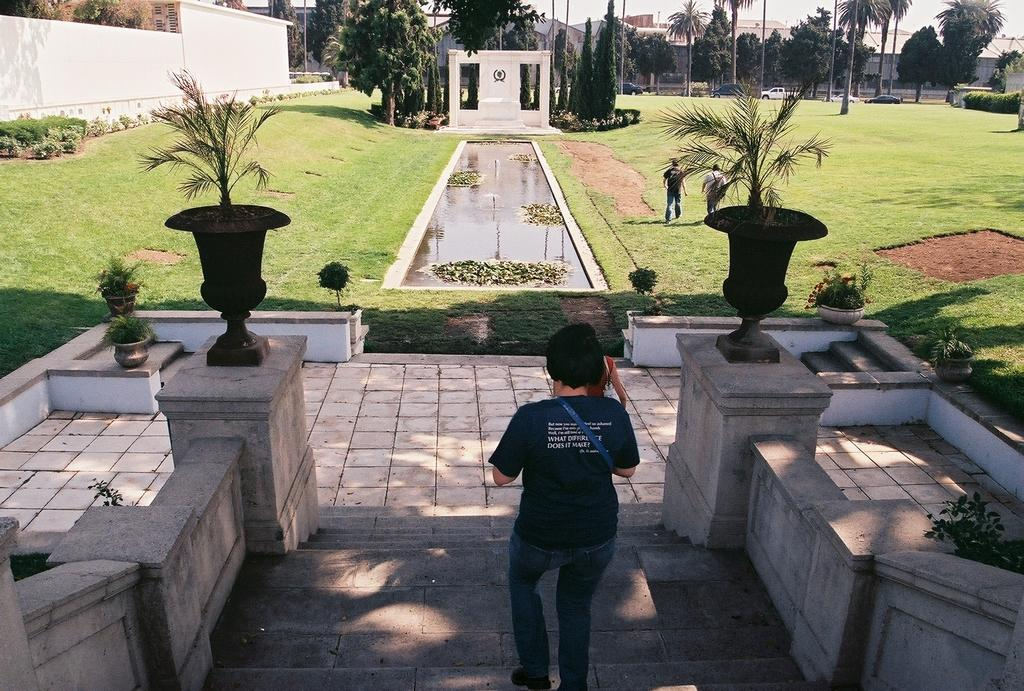How many people are in the image? There are people in the image, but the exact number is not specified. What can be seen in the image besides the people? There are stairs, plants, trees, a pond, buildings, cars, and the sky visible in the image. What type of vegetation is present in the image? There are plants and trees in the image. What is the setting of the image? The image features a combination of natural elements (plants, trees, pond, grass) and man-made structures (stairs, buildings, cars). What is visible in the background of the image? In the background of the image, there are buildings, cars, and the sky. What type of mask is the person wearing in the image? There is no mention of a mask or any person wearing a mask in the image. What part of the person's body is adorned with a crown in the image? There is no mention of a crown or any person wearing a crown in the image. 